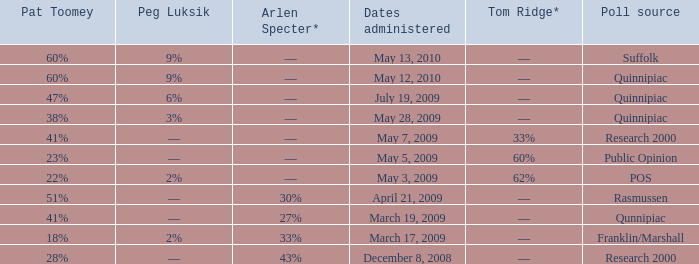Which Poll source has Pat Toomey of 23%? Public Opinion. 